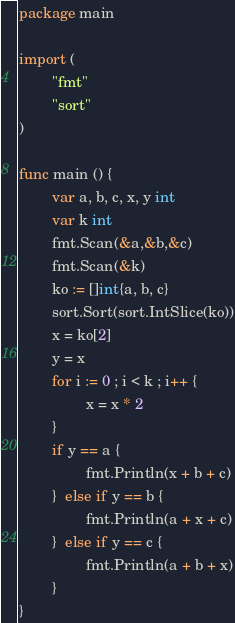Convert code to text. <code><loc_0><loc_0><loc_500><loc_500><_Go_>package main 

import (
        "fmt"
        "sort"
)

func main () {
        var a, b, c, x, y int
        var k int
        fmt.Scan(&a,&b,&c)
        fmt.Scan(&k)
        ko := []int{a, b, c}
        sort.Sort(sort.IntSlice(ko))
        x = ko[2]
        y = x 
        for i := 0 ; i < k ; i++ {
                x = x * 2
        }
        if y == a {
                fmt.Println(x + b + c)
        }  else if y == b {
                fmt.Println(a + x + c)
        }  else if y == c {
                fmt.Println(a + b + x)
        }
}
</code> 